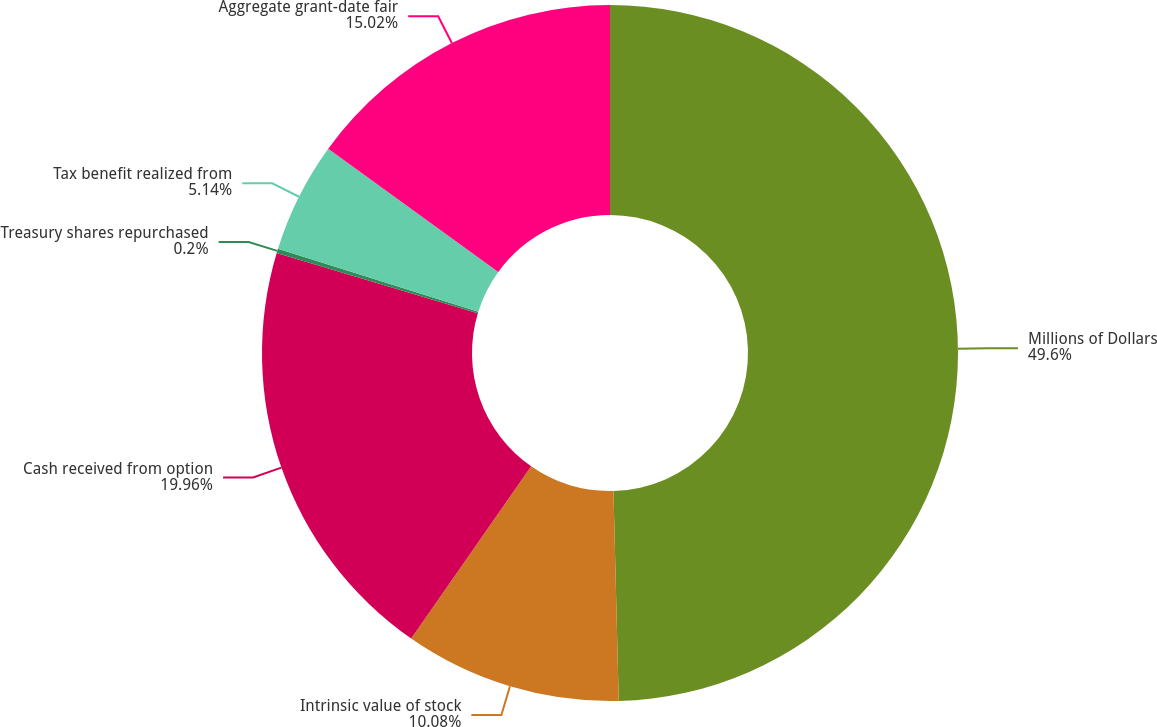Convert chart. <chart><loc_0><loc_0><loc_500><loc_500><pie_chart><fcel>Millions of Dollars<fcel>Intrinsic value of stock<fcel>Cash received from option<fcel>Treasury shares repurchased<fcel>Tax benefit realized from<fcel>Aggregate grant-date fair<nl><fcel>49.6%<fcel>10.08%<fcel>19.96%<fcel>0.2%<fcel>5.14%<fcel>15.02%<nl></chart> 